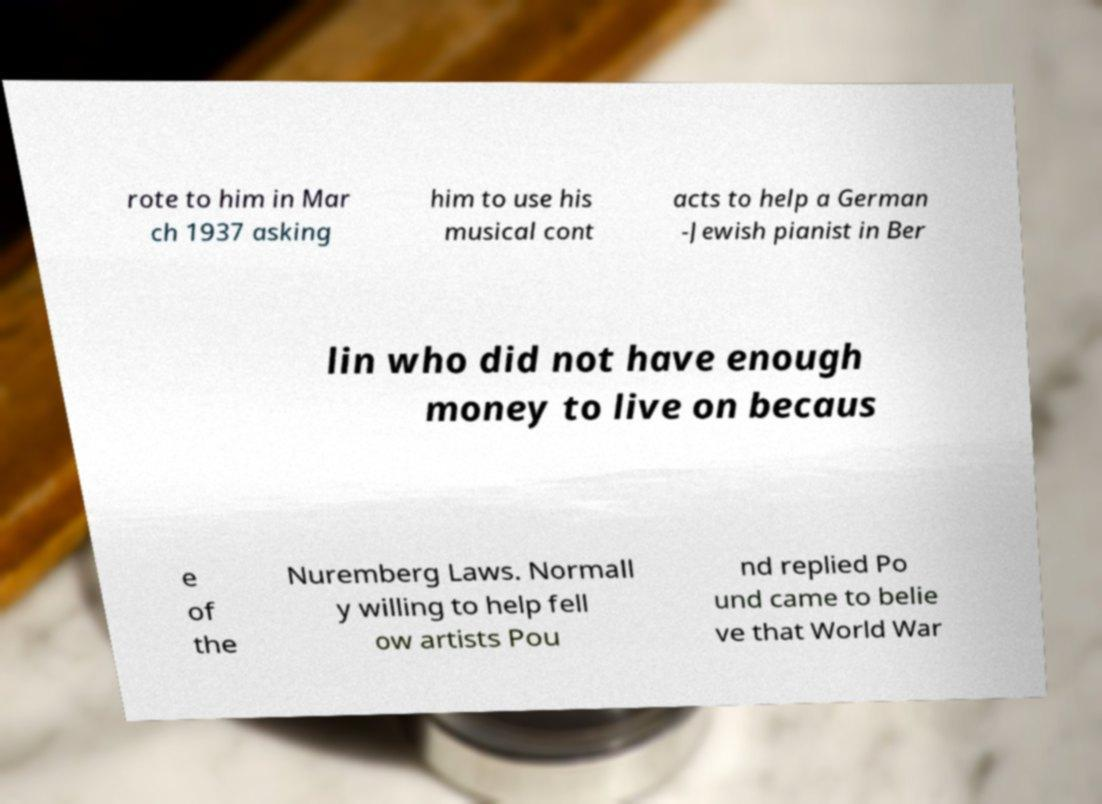For documentation purposes, I need the text within this image transcribed. Could you provide that? rote to him in Mar ch 1937 asking him to use his musical cont acts to help a German -Jewish pianist in Ber lin who did not have enough money to live on becaus e of the Nuremberg Laws. Normall y willing to help fell ow artists Pou nd replied Po und came to belie ve that World War 